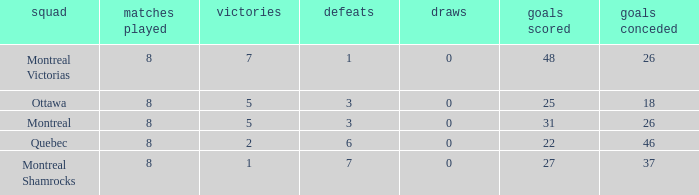For teams with fewer than 5 wins, goals against over 37, and fewer than 8 games played, what is the average number of ties? None. 